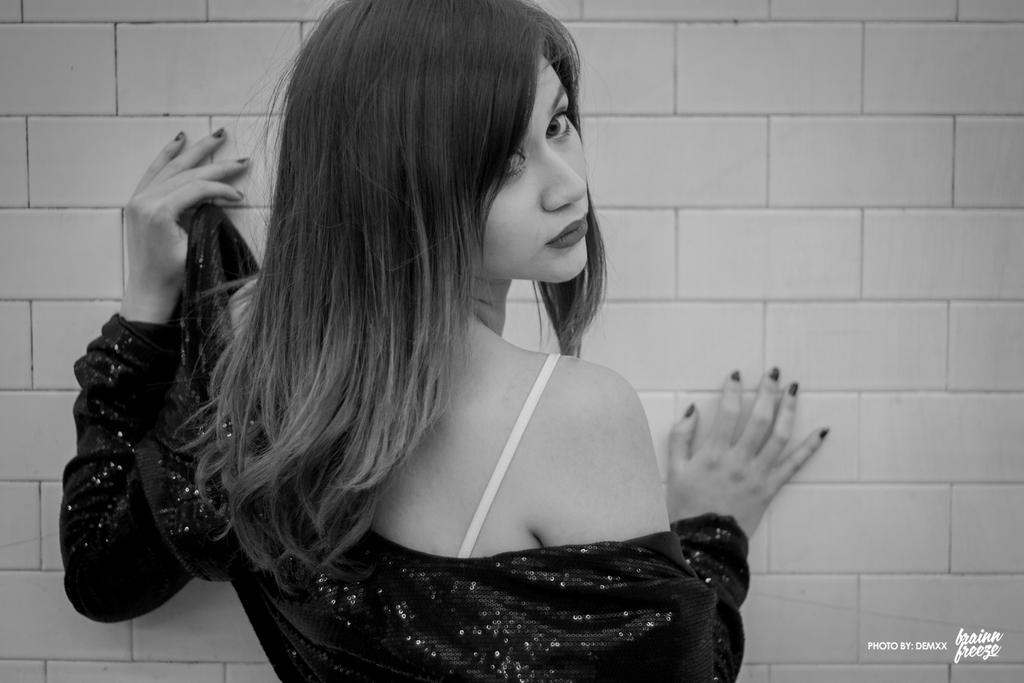Who is present in the image? There is a woman in the image. What is in front of the woman? There is a wall in front of the woman. Can you describe any additional features of the image? There is a watermark at the right bottom of the image. What channel does the woman watch on her television in the image? There is no television present in the image, so it is not possible to determine what channel the woman might be watching. 